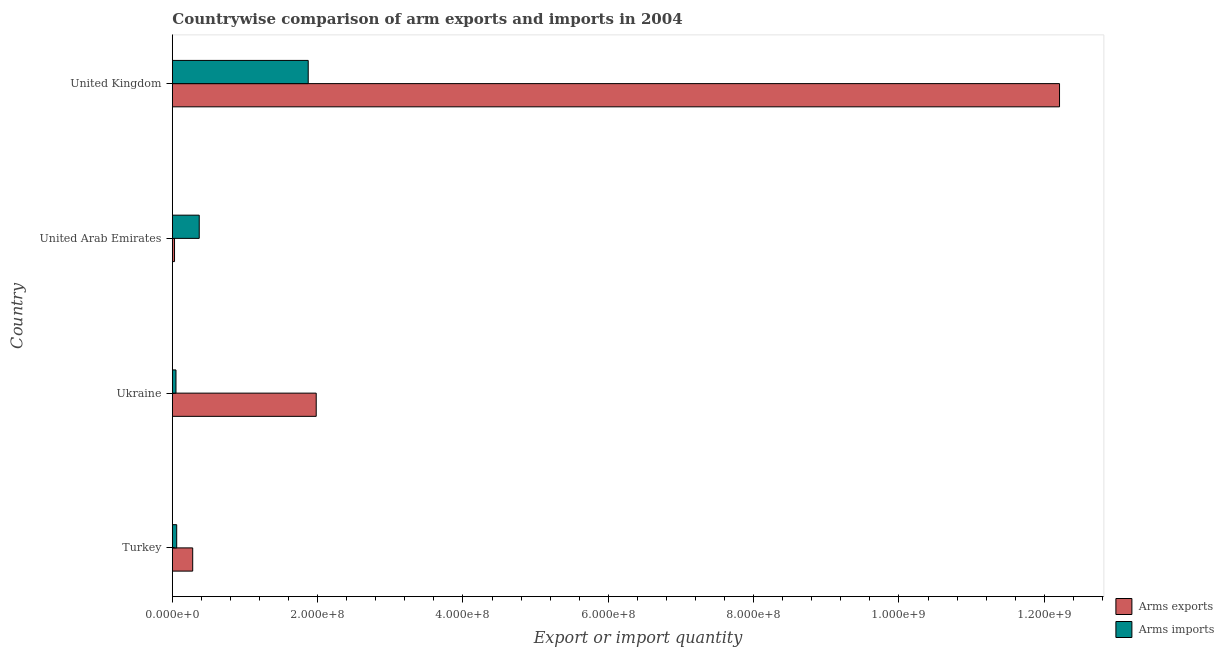How many groups of bars are there?
Offer a terse response. 4. How many bars are there on the 2nd tick from the bottom?
Your answer should be compact. 2. What is the arms imports in Turkey?
Make the answer very short. 6.00e+06. Across all countries, what is the maximum arms imports?
Keep it short and to the point. 1.87e+08. Across all countries, what is the minimum arms imports?
Your response must be concise. 5.00e+06. In which country was the arms imports maximum?
Make the answer very short. United Kingdom. In which country was the arms imports minimum?
Provide a short and direct response. Ukraine. What is the total arms exports in the graph?
Make the answer very short. 1.45e+09. What is the difference between the arms exports in United Arab Emirates and that in United Kingdom?
Provide a succinct answer. -1.22e+09. What is the difference between the arms exports in United Kingdom and the arms imports in Turkey?
Make the answer very short. 1.22e+09. What is the average arms exports per country?
Ensure brevity in your answer.  3.62e+08. What is the difference between the arms imports and arms exports in United Kingdom?
Ensure brevity in your answer.  -1.03e+09. What is the ratio of the arms exports in Turkey to that in United Arab Emirates?
Your response must be concise. 9.33. What is the difference between the highest and the second highest arms exports?
Your answer should be compact. 1.02e+09. What is the difference between the highest and the lowest arms imports?
Offer a terse response. 1.82e+08. What does the 2nd bar from the top in United Arab Emirates represents?
Offer a terse response. Arms exports. What does the 2nd bar from the bottom in Ukraine represents?
Give a very brief answer. Arms imports. Are all the bars in the graph horizontal?
Your answer should be very brief. Yes. How many countries are there in the graph?
Your response must be concise. 4. What is the difference between two consecutive major ticks on the X-axis?
Your response must be concise. 2.00e+08. Does the graph contain any zero values?
Your answer should be very brief. No. How many legend labels are there?
Keep it short and to the point. 2. How are the legend labels stacked?
Keep it short and to the point. Vertical. What is the title of the graph?
Your response must be concise. Countrywise comparison of arm exports and imports in 2004. What is the label or title of the X-axis?
Your response must be concise. Export or import quantity. What is the Export or import quantity in Arms exports in Turkey?
Your response must be concise. 2.80e+07. What is the Export or import quantity in Arms exports in Ukraine?
Make the answer very short. 1.98e+08. What is the Export or import quantity in Arms exports in United Arab Emirates?
Keep it short and to the point. 3.00e+06. What is the Export or import quantity in Arms imports in United Arab Emirates?
Provide a succinct answer. 3.70e+07. What is the Export or import quantity in Arms exports in United Kingdom?
Keep it short and to the point. 1.22e+09. What is the Export or import quantity in Arms imports in United Kingdom?
Provide a short and direct response. 1.87e+08. Across all countries, what is the maximum Export or import quantity of Arms exports?
Provide a short and direct response. 1.22e+09. Across all countries, what is the maximum Export or import quantity of Arms imports?
Give a very brief answer. 1.87e+08. Across all countries, what is the minimum Export or import quantity in Arms exports?
Your answer should be compact. 3.00e+06. Across all countries, what is the minimum Export or import quantity of Arms imports?
Offer a terse response. 5.00e+06. What is the total Export or import quantity in Arms exports in the graph?
Your answer should be compact. 1.45e+09. What is the total Export or import quantity in Arms imports in the graph?
Make the answer very short. 2.35e+08. What is the difference between the Export or import quantity in Arms exports in Turkey and that in Ukraine?
Offer a terse response. -1.70e+08. What is the difference between the Export or import quantity of Arms exports in Turkey and that in United Arab Emirates?
Your answer should be very brief. 2.50e+07. What is the difference between the Export or import quantity in Arms imports in Turkey and that in United Arab Emirates?
Your answer should be compact. -3.10e+07. What is the difference between the Export or import quantity in Arms exports in Turkey and that in United Kingdom?
Your response must be concise. -1.19e+09. What is the difference between the Export or import quantity of Arms imports in Turkey and that in United Kingdom?
Make the answer very short. -1.81e+08. What is the difference between the Export or import quantity of Arms exports in Ukraine and that in United Arab Emirates?
Offer a terse response. 1.95e+08. What is the difference between the Export or import quantity in Arms imports in Ukraine and that in United Arab Emirates?
Your answer should be very brief. -3.20e+07. What is the difference between the Export or import quantity in Arms exports in Ukraine and that in United Kingdom?
Ensure brevity in your answer.  -1.02e+09. What is the difference between the Export or import quantity of Arms imports in Ukraine and that in United Kingdom?
Make the answer very short. -1.82e+08. What is the difference between the Export or import quantity of Arms exports in United Arab Emirates and that in United Kingdom?
Your answer should be compact. -1.22e+09. What is the difference between the Export or import quantity in Arms imports in United Arab Emirates and that in United Kingdom?
Your response must be concise. -1.50e+08. What is the difference between the Export or import quantity of Arms exports in Turkey and the Export or import quantity of Arms imports in Ukraine?
Provide a succinct answer. 2.30e+07. What is the difference between the Export or import quantity in Arms exports in Turkey and the Export or import quantity in Arms imports in United Arab Emirates?
Your response must be concise. -9.00e+06. What is the difference between the Export or import quantity in Arms exports in Turkey and the Export or import quantity in Arms imports in United Kingdom?
Offer a terse response. -1.59e+08. What is the difference between the Export or import quantity in Arms exports in Ukraine and the Export or import quantity in Arms imports in United Arab Emirates?
Offer a very short reply. 1.61e+08. What is the difference between the Export or import quantity in Arms exports in Ukraine and the Export or import quantity in Arms imports in United Kingdom?
Ensure brevity in your answer.  1.10e+07. What is the difference between the Export or import quantity of Arms exports in United Arab Emirates and the Export or import quantity of Arms imports in United Kingdom?
Provide a short and direct response. -1.84e+08. What is the average Export or import quantity in Arms exports per country?
Provide a short and direct response. 3.62e+08. What is the average Export or import quantity of Arms imports per country?
Make the answer very short. 5.88e+07. What is the difference between the Export or import quantity of Arms exports and Export or import quantity of Arms imports in Turkey?
Give a very brief answer. 2.20e+07. What is the difference between the Export or import quantity of Arms exports and Export or import quantity of Arms imports in Ukraine?
Provide a short and direct response. 1.93e+08. What is the difference between the Export or import quantity in Arms exports and Export or import quantity in Arms imports in United Arab Emirates?
Provide a short and direct response. -3.40e+07. What is the difference between the Export or import quantity of Arms exports and Export or import quantity of Arms imports in United Kingdom?
Your response must be concise. 1.03e+09. What is the ratio of the Export or import quantity in Arms exports in Turkey to that in Ukraine?
Offer a very short reply. 0.14. What is the ratio of the Export or import quantity of Arms imports in Turkey to that in Ukraine?
Ensure brevity in your answer.  1.2. What is the ratio of the Export or import quantity of Arms exports in Turkey to that in United Arab Emirates?
Make the answer very short. 9.33. What is the ratio of the Export or import quantity in Arms imports in Turkey to that in United Arab Emirates?
Provide a short and direct response. 0.16. What is the ratio of the Export or import quantity of Arms exports in Turkey to that in United Kingdom?
Give a very brief answer. 0.02. What is the ratio of the Export or import quantity of Arms imports in Turkey to that in United Kingdom?
Make the answer very short. 0.03. What is the ratio of the Export or import quantity of Arms exports in Ukraine to that in United Arab Emirates?
Ensure brevity in your answer.  66. What is the ratio of the Export or import quantity in Arms imports in Ukraine to that in United Arab Emirates?
Ensure brevity in your answer.  0.14. What is the ratio of the Export or import quantity of Arms exports in Ukraine to that in United Kingdom?
Your answer should be compact. 0.16. What is the ratio of the Export or import quantity in Arms imports in Ukraine to that in United Kingdom?
Your answer should be compact. 0.03. What is the ratio of the Export or import quantity of Arms exports in United Arab Emirates to that in United Kingdom?
Your answer should be very brief. 0. What is the ratio of the Export or import quantity in Arms imports in United Arab Emirates to that in United Kingdom?
Make the answer very short. 0.2. What is the difference between the highest and the second highest Export or import quantity in Arms exports?
Your answer should be very brief. 1.02e+09. What is the difference between the highest and the second highest Export or import quantity in Arms imports?
Make the answer very short. 1.50e+08. What is the difference between the highest and the lowest Export or import quantity in Arms exports?
Keep it short and to the point. 1.22e+09. What is the difference between the highest and the lowest Export or import quantity of Arms imports?
Ensure brevity in your answer.  1.82e+08. 